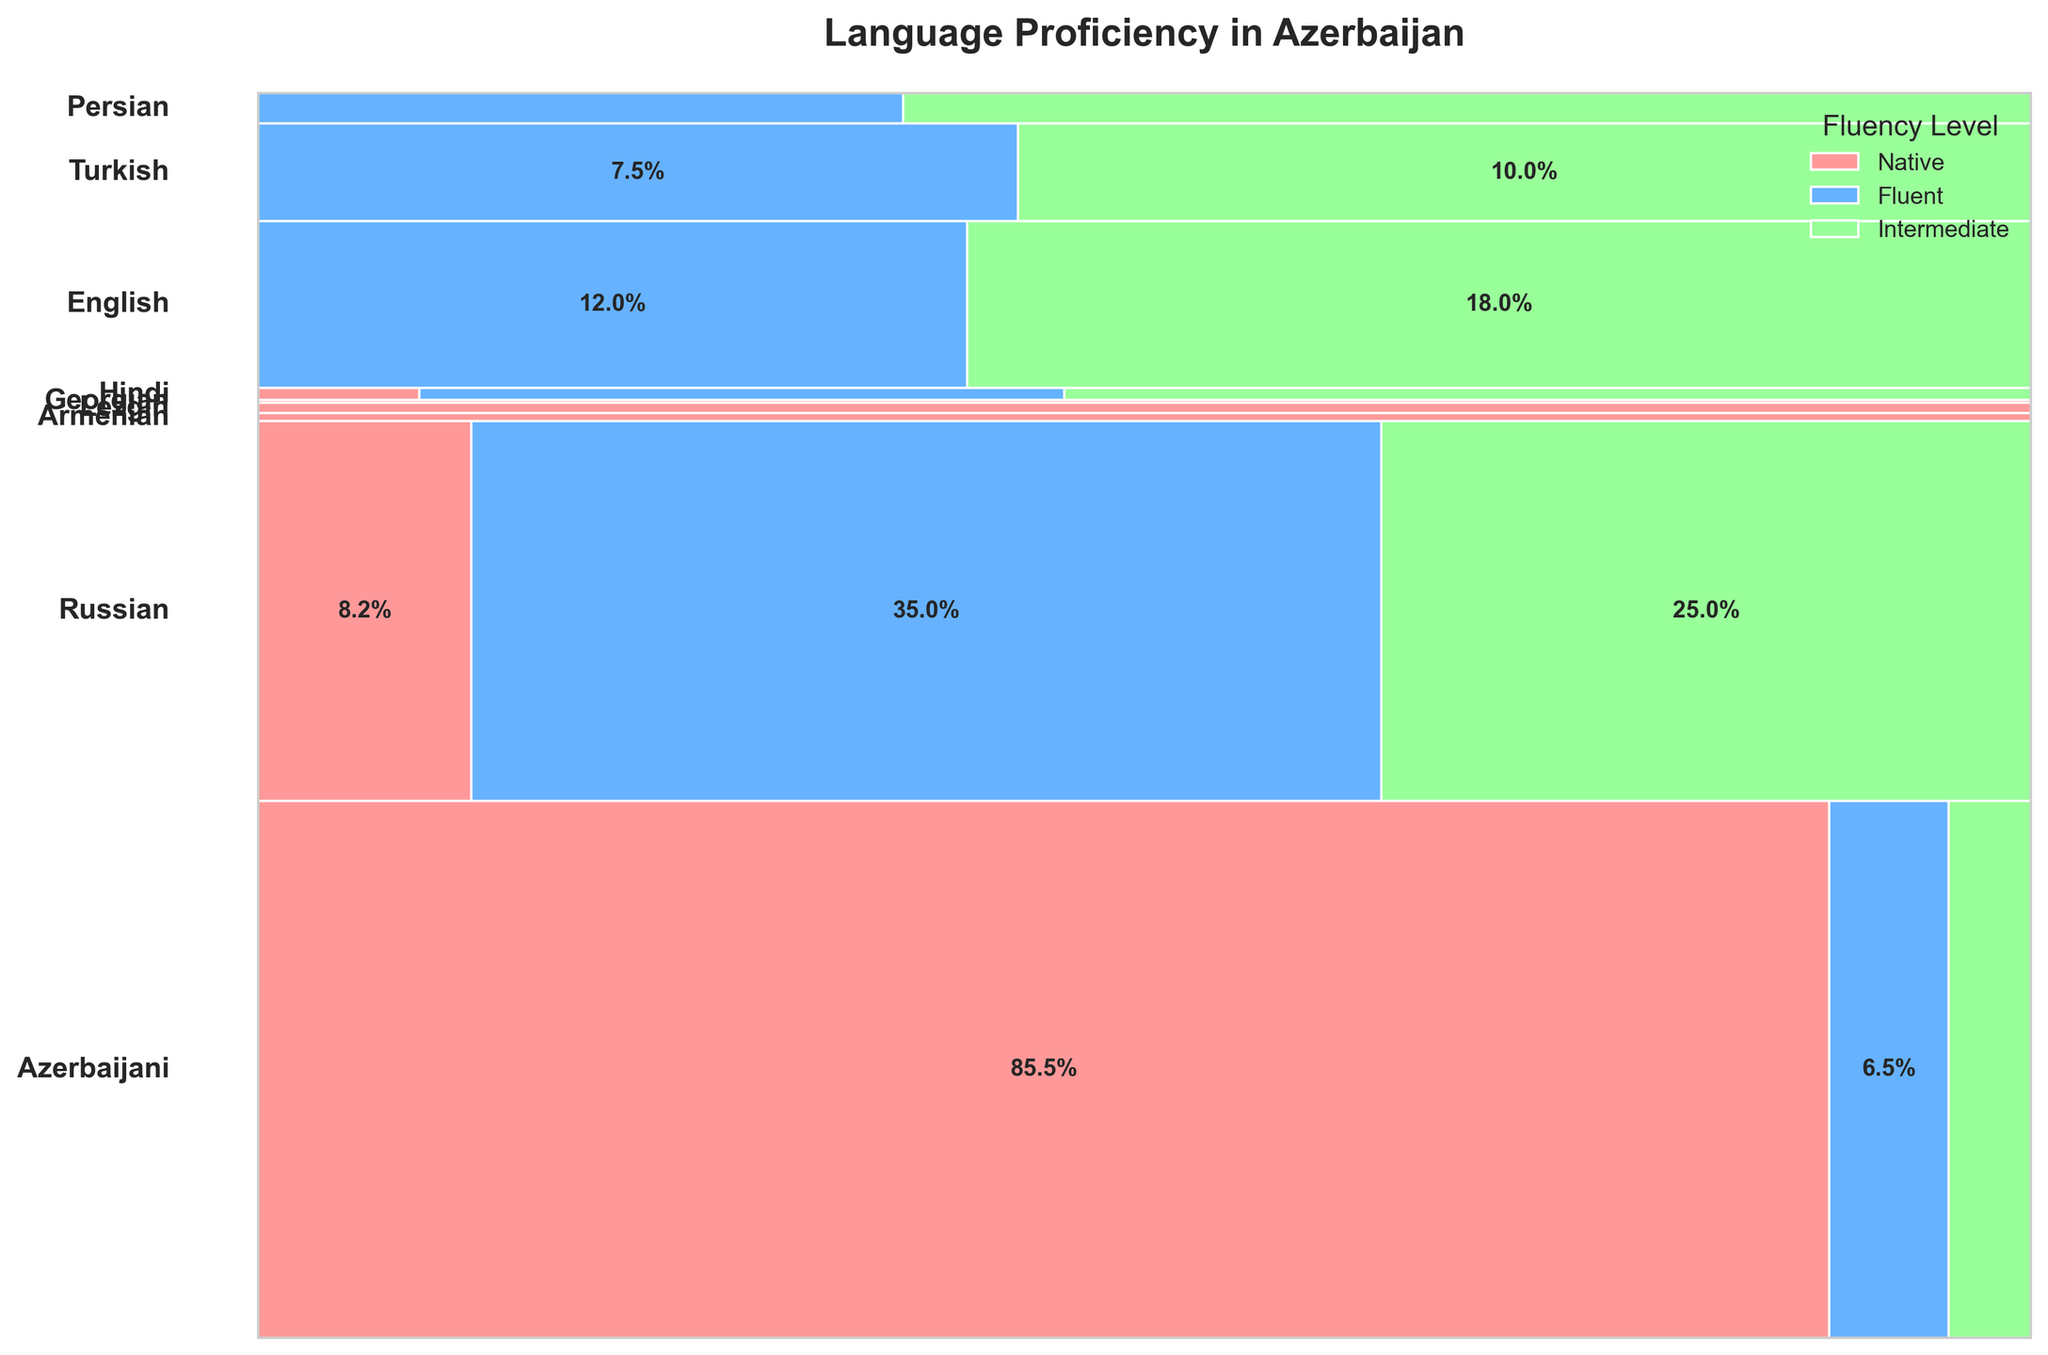What's the fluency level with the highest percentage for Azerbaijani speakers? The segment representing the Azerbaijani language has the highest percentage assigned to the "Native" fluency level.
Answer: Azerbaijani Native How many languages have non-zero percentages in the "Intermediate" fluency level? The plot shows that Azerbaijani, Russian, English, Turkish, Persian, and Hindi have non-zero segments in the "Intermediate" fluency level.
Answer: 6 Which language has the smallest percentage of native speakers? The segments for "Native" fluency level are compared, and Hindi has the smallest percentage for native speakers.
Answer: Hindi What is the combined percentage of fluent English and fluent Russian speakers? Add the percentages for English fluent (12.0%) and Russian fluent (35.0%) from their respective segments.
Answer: 47.0% Are there more native Russian speakers or fluent Russian speakers? Compare the size of the segments: native Russian speakers (8.2%) with fluent Russian speakers (35.0%).
Answer: Fluent Russian speakers Which languages appear in all three fluency levels shown in the plot? By checking each segment, it is evident that Azerbaijani, Russian, and Hindi appear in all three fluency levels.
Answer: Azerbaijani, Russian, Hindi What is the total percentage of speakers who are fluent in Turkish? The segment for fluent Turkish speakers shows a percentage of 7.5%.
Answer: 7.5% Which fluency level has the smallest representation across all languages? Upon visual inspection, the "Native" and "Fluent" levels have larger segments across languages compared to "Intermediate" levels.
Answer: Intermediate Compare the percentage of intermediate English speakers to fluent Turkish speakers. Which is higher? Check the sizes of the segments: intermediate English (18.0%) and fluent Turkish (7.5%).
Answer: Intermediate English What is the percentage difference between native and intermediate speakers of Azerbaijani? Subtract the intermediate Azerbaijani percentage (4.5%) from the native Azerbaijani percentage (85.5%).
Answer: 81.0% 